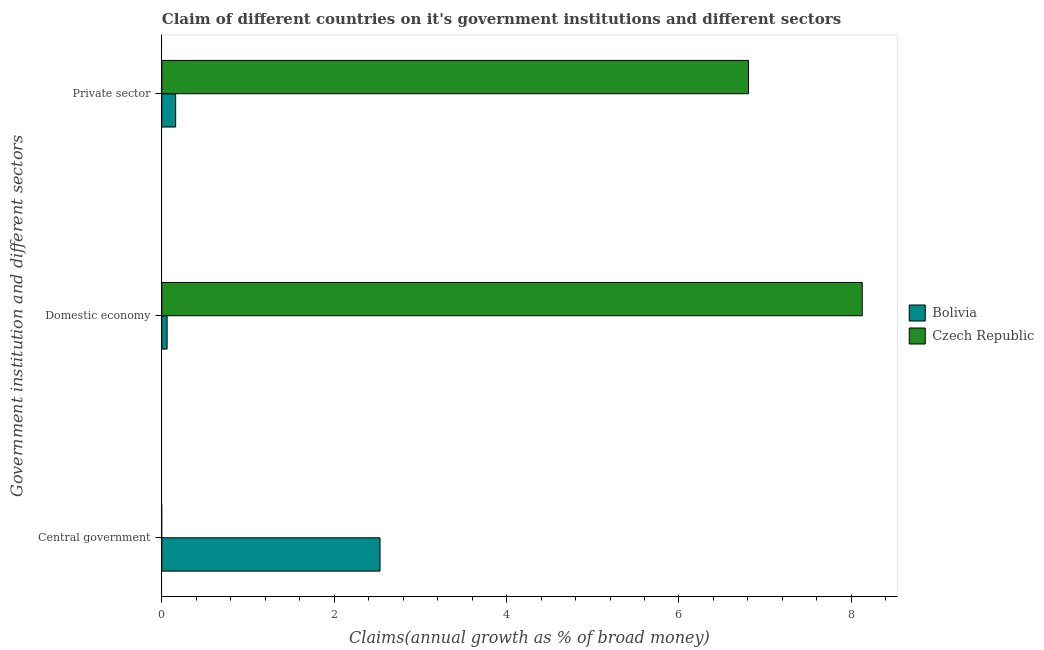How many different coloured bars are there?
Keep it short and to the point. 2. Are the number of bars per tick equal to the number of legend labels?
Provide a succinct answer. No. What is the label of the 1st group of bars from the top?
Offer a very short reply. Private sector. What is the percentage of claim on the private sector in Czech Republic?
Give a very brief answer. 6.81. Across all countries, what is the maximum percentage of claim on the domestic economy?
Provide a short and direct response. 8.13. In which country was the percentage of claim on the domestic economy maximum?
Your answer should be compact. Czech Republic. What is the total percentage of claim on the domestic economy in the graph?
Your answer should be compact. 8.19. What is the difference between the percentage of claim on the private sector in Czech Republic and that in Bolivia?
Your response must be concise. 6.65. What is the difference between the percentage of claim on the domestic economy in Bolivia and the percentage of claim on the private sector in Czech Republic?
Make the answer very short. -6.75. What is the average percentage of claim on the private sector per country?
Offer a very short reply. 3.48. What is the difference between the percentage of claim on the domestic economy and percentage of claim on the private sector in Czech Republic?
Your response must be concise. 1.32. In how many countries, is the percentage of claim on the central government greater than 1.2000000000000002 %?
Your answer should be compact. 1. What is the ratio of the percentage of claim on the private sector in Bolivia to that in Czech Republic?
Your answer should be compact. 0.02. What is the difference between the highest and the second highest percentage of claim on the domestic economy?
Keep it short and to the point. 8.07. What is the difference between the highest and the lowest percentage of claim on the domestic economy?
Your response must be concise. 8.07. In how many countries, is the percentage of claim on the domestic economy greater than the average percentage of claim on the domestic economy taken over all countries?
Offer a terse response. 1. Is the sum of the percentage of claim on the domestic economy in Bolivia and Czech Republic greater than the maximum percentage of claim on the private sector across all countries?
Your answer should be very brief. Yes. Is it the case that in every country, the sum of the percentage of claim on the central government and percentage of claim on the domestic economy is greater than the percentage of claim on the private sector?
Provide a succinct answer. Yes. How many bars are there?
Provide a succinct answer. 5. How many countries are there in the graph?
Keep it short and to the point. 2. What is the difference between two consecutive major ticks on the X-axis?
Offer a terse response. 2. How are the legend labels stacked?
Your answer should be compact. Vertical. What is the title of the graph?
Your response must be concise. Claim of different countries on it's government institutions and different sectors. What is the label or title of the X-axis?
Keep it short and to the point. Claims(annual growth as % of broad money). What is the label or title of the Y-axis?
Give a very brief answer. Government institution and different sectors. What is the Claims(annual growth as % of broad money) in Bolivia in Central government?
Your answer should be very brief. 2.53. What is the Claims(annual growth as % of broad money) in Bolivia in Domestic economy?
Provide a short and direct response. 0.06. What is the Claims(annual growth as % of broad money) in Czech Republic in Domestic economy?
Offer a very short reply. 8.13. What is the Claims(annual growth as % of broad money) of Bolivia in Private sector?
Provide a short and direct response. 0.16. What is the Claims(annual growth as % of broad money) in Czech Republic in Private sector?
Make the answer very short. 6.81. Across all Government institution and different sectors, what is the maximum Claims(annual growth as % of broad money) of Bolivia?
Your answer should be very brief. 2.53. Across all Government institution and different sectors, what is the maximum Claims(annual growth as % of broad money) of Czech Republic?
Make the answer very short. 8.13. Across all Government institution and different sectors, what is the minimum Claims(annual growth as % of broad money) of Bolivia?
Offer a terse response. 0.06. What is the total Claims(annual growth as % of broad money) of Bolivia in the graph?
Your answer should be very brief. 2.75. What is the total Claims(annual growth as % of broad money) of Czech Republic in the graph?
Provide a succinct answer. 14.93. What is the difference between the Claims(annual growth as % of broad money) in Bolivia in Central government and that in Domestic economy?
Offer a terse response. 2.47. What is the difference between the Claims(annual growth as % of broad money) of Bolivia in Central government and that in Private sector?
Offer a very short reply. 2.37. What is the difference between the Claims(annual growth as % of broad money) in Bolivia in Domestic economy and that in Private sector?
Ensure brevity in your answer.  -0.1. What is the difference between the Claims(annual growth as % of broad money) of Czech Republic in Domestic economy and that in Private sector?
Provide a succinct answer. 1.32. What is the difference between the Claims(annual growth as % of broad money) in Bolivia in Central government and the Claims(annual growth as % of broad money) in Czech Republic in Domestic economy?
Your answer should be compact. -5.59. What is the difference between the Claims(annual growth as % of broad money) in Bolivia in Central government and the Claims(annual growth as % of broad money) in Czech Republic in Private sector?
Ensure brevity in your answer.  -4.28. What is the difference between the Claims(annual growth as % of broad money) of Bolivia in Domestic economy and the Claims(annual growth as % of broad money) of Czech Republic in Private sector?
Your answer should be very brief. -6.75. What is the average Claims(annual growth as % of broad money) in Bolivia per Government institution and different sectors?
Your answer should be compact. 0.92. What is the average Claims(annual growth as % of broad money) of Czech Republic per Government institution and different sectors?
Make the answer very short. 4.98. What is the difference between the Claims(annual growth as % of broad money) in Bolivia and Claims(annual growth as % of broad money) in Czech Republic in Domestic economy?
Ensure brevity in your answer.  -8.07. What is the difference between the Claims(annual growth as % of broad money) of Bolivia and Claims(annual growth as % of broad money) of Czech Republic in Private sector?
Give a very brief answer. -6.65. What is the ratio of the Claims(annual growth as % of broad money) of Bolivia in Central government to that in Domestic economy?
Your response must be concise. 41.32. What is the ratio of the Claims(annual growth as % of broad money) in Bolivia in Central government to that in Private sector?
Provide a succinct answer. 15.78. What is the ratio of the Claims(annual growth as % of broad money) of Bolivia in Domestic economy to that in Private sector?
Give a very brief answer. 0.38. What is the ratio of the Claims(annual growth as % of broad money) in Czech Republic in Domestic economy to that in Private sector?
Give a very brief answer. 1.19. What is the difference between the highest and the second highest Claims(annual growth as % of broad money) of Bolivia?
Your answer should be very brief. 2.37. What is the difference between the highest and the lowest Claims(annual growth as % of broad money) of Bolivia?
Give a very brief answer. 2.47. What is the difference between the highest and the lowest Claims(annual growth as % of broad money) of Czech Republic?
Your answer should be very brief. 8.13. 